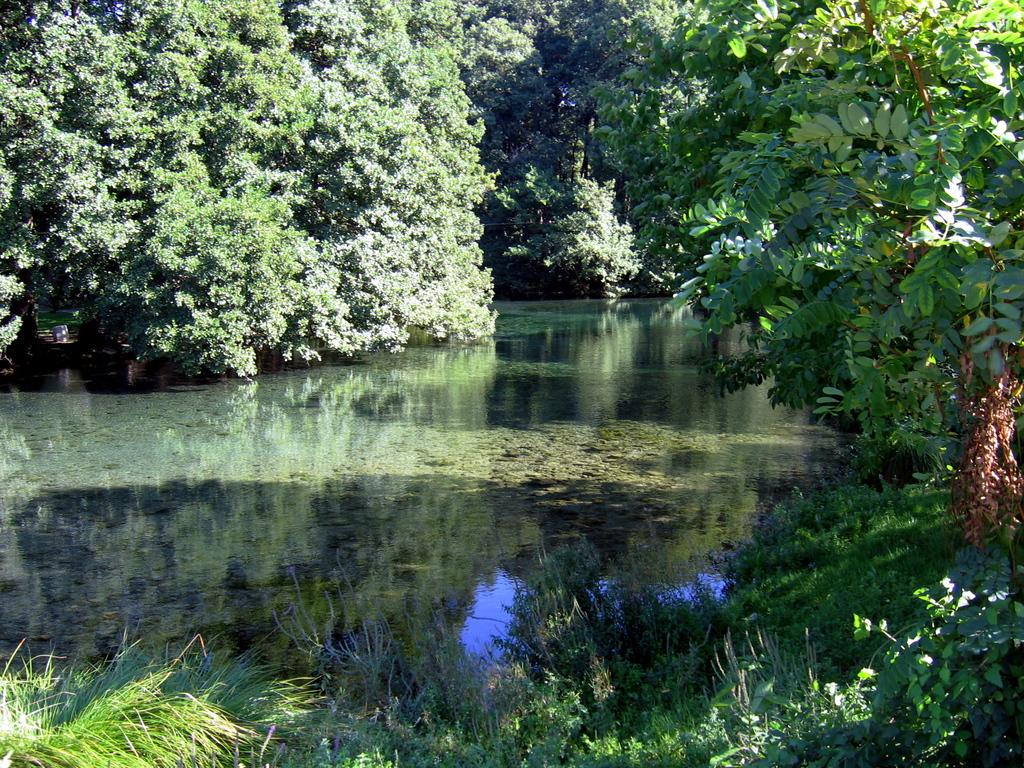What is located in the middle of the image? There is water in the middle of the image. What can be seen in the background of the image? There are many trees in the background of the image. What type of vegetation is at the bottom of the image? There is grass at the bottom of the image. What is present to the right of the image? There are plants to the right of the image. What color is the daughter's shirt in the image? There is no daughter or shirt present in the image. 